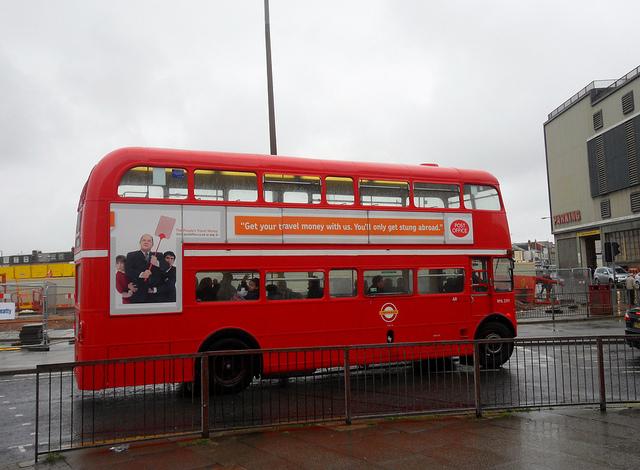What color is the bus?
Keep it brief. Red. How many people are on the bus?
Keep it brief. 10. What bright color is the building in the left background?
Write a very short answer. Yellow. What color is building?
Quick response, please. White. What number of windows are on the second story of this bus?
Keep it brief. 7. 